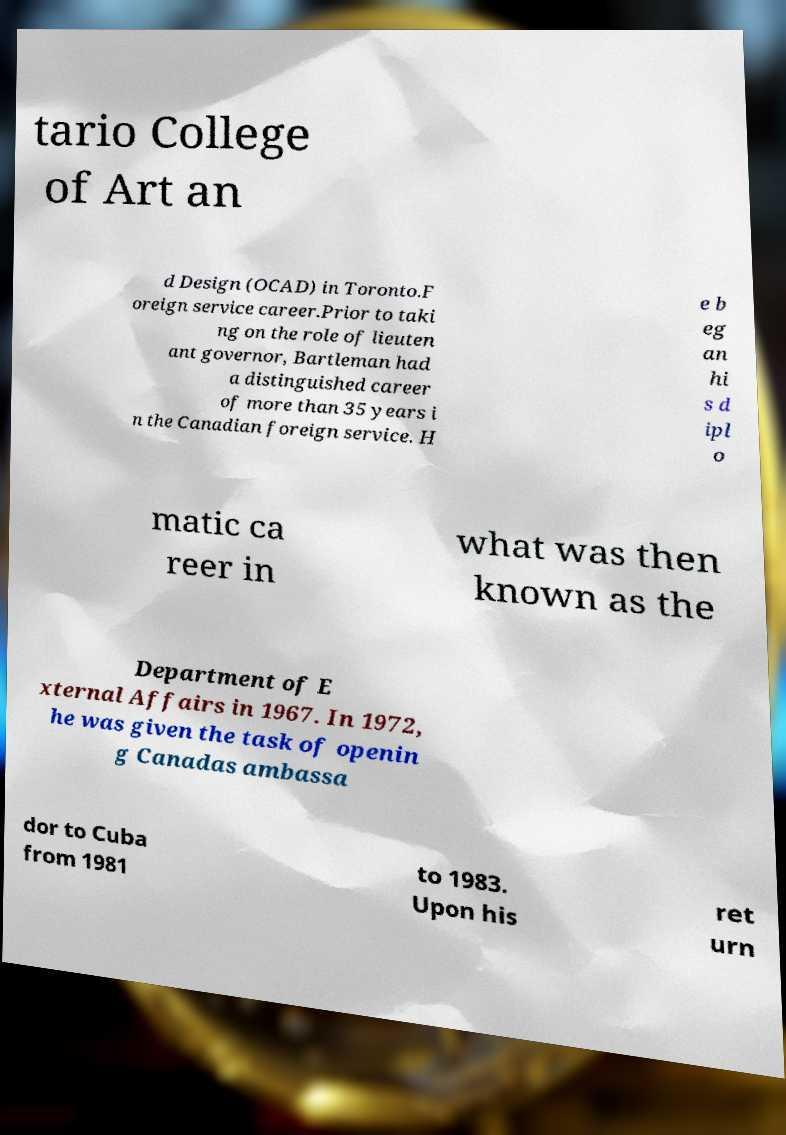I need the written content from this picture converted into text. Can you do that? tario College of Art an d Design (OCAD) in Toronto.F oreign service career.Prior to taki ng on the role of lieuten ant governor, Bartleman had a distinguished career of more than 35 years i n the Canadian foreign service. H e b eg an hi s d ipl o matic ca reer in what was then known as the Department of E xternal Affairs in 1967. In 1972, he was given the task of openin g Canadas ambassa dor to Cuba from 1981 to 1983. Upon his ret urn 